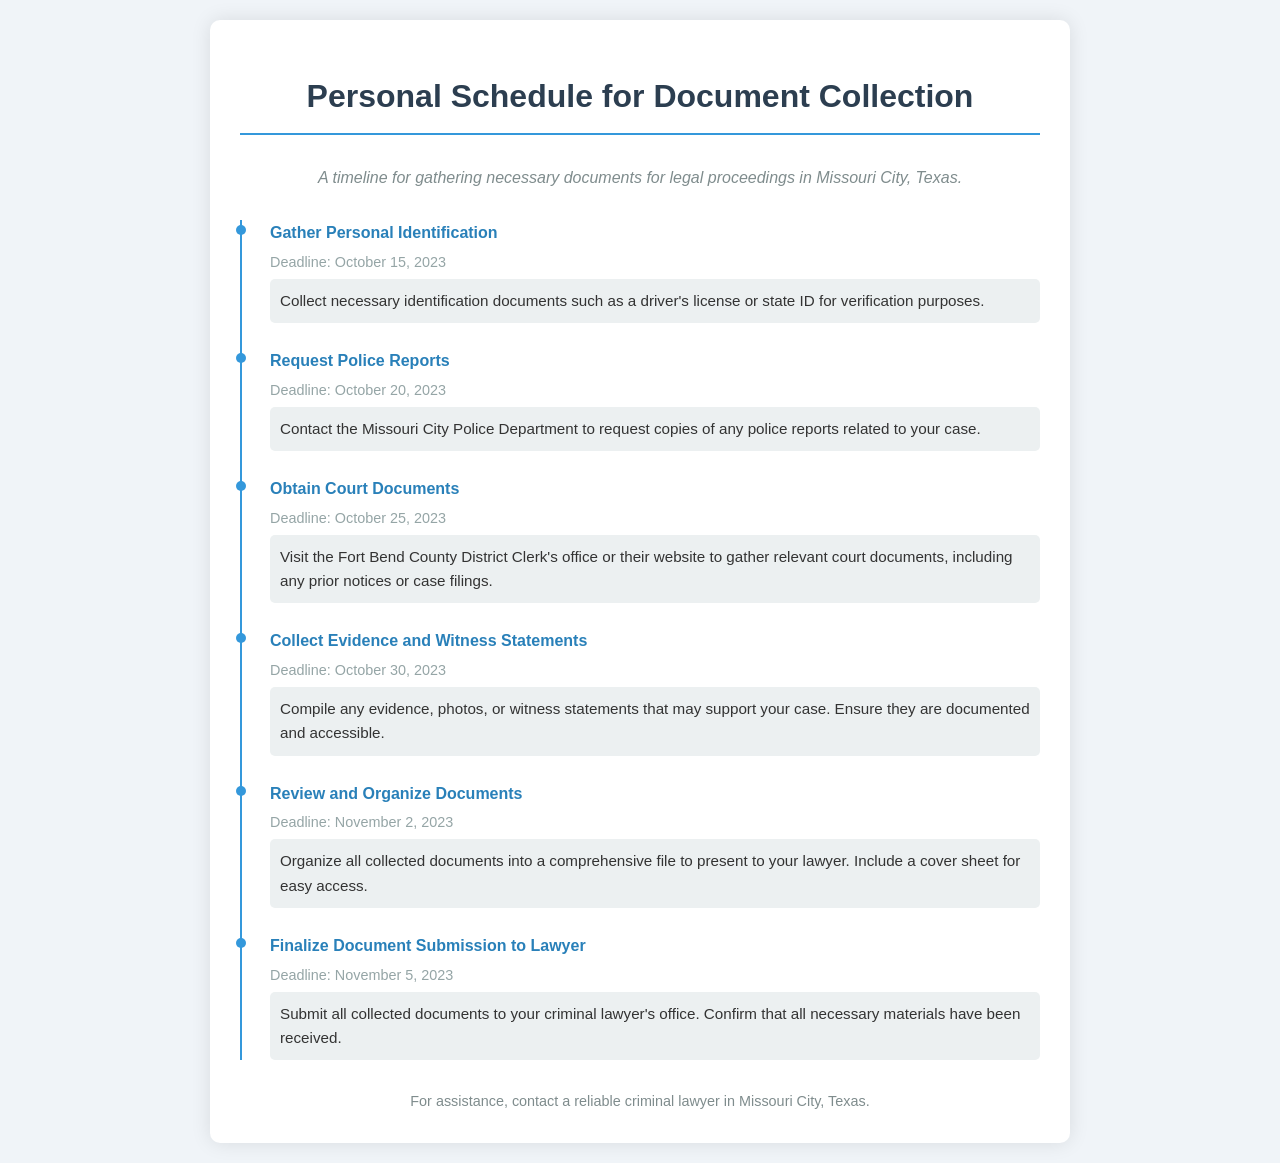What is the deadline for gathering personal identification? The deadline for gathering personal identification is stated clearly in the document.
Answer: October 15, 2023 What task should be completed by October 20, 2023? The task to be completed by that date is explicitly mentioned in the timeline section.
Answer: Request Police Reports How many days do you have to collect evidence and witness statements? The timeline indicates the deadline for this task and the starting date allows calculating the duration.
Answer: 5 days What is one type of document you need to obtain from the Fort Bend County District Clerk's office? The document type is directly stated in the relevant task details.
Answer: Court Documents What is the final deadline for submitting documents to your lawyer? The deadline is provided in the timeline section, marking the final submission date.
Answer: November 5, 2023 List one document needed for verification purposes. The document needed for verification is clearly mentioned in the first task details.
Answer: Driver's license What is the purpose of organizing all collected documents? The purpose is described in the details of the task, emphasizing the need for presentation to a lawyer.
Answer: Presentation to your lawyer Which task requires contacting the Missouri City Police Department? The task requiring contact with the police department is specified in the timeline.
Answer: Request Police Reports 